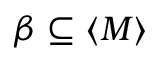Convert formula to latex. <formula><loc_0><loc_0><loc_500><loc_500>\beta \subseteq \langle M \rangle</formula> 